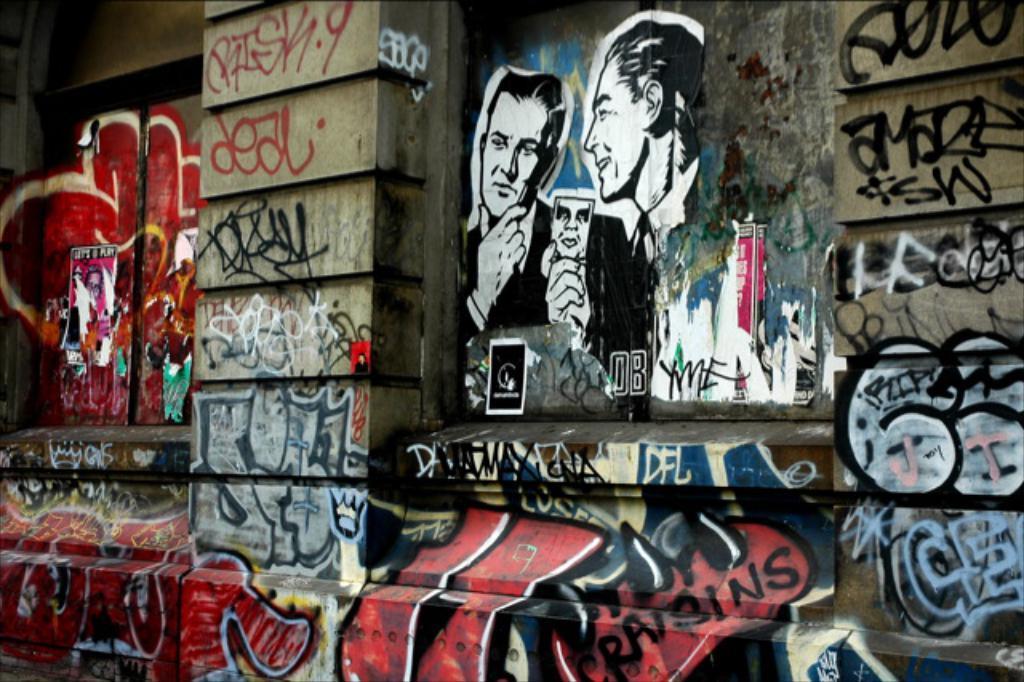In one or two sentences, can you explain what this image depicts? In this image there is graffiti on the wall. 